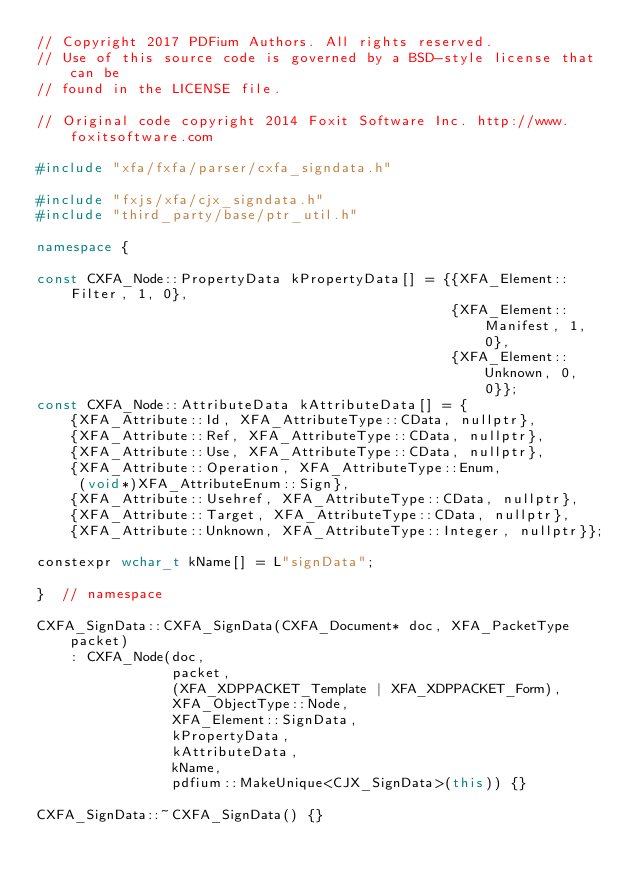<code> <loc_0><loc_0><loc_500><loc_500><_C++_>// Copyright 2017 PDFium Authors. All rights reserved.
// Use of this source code is governed by a BSD-style license that can be
// found in the LICENSE file.

// Original code copyright 2014 Foxit Software Inc. http://www.foxitsoftware.com

#include "xfa/fxfa/parser/cxfa_signdata.h"

#include "fxjs/xfa/cjx_signdata.h"
#include "third_party/base/ptr_util.h"

namespace {

const CXFA_Node::PropertyData kPropertyData[] = {{XFA_Element::Filter, 1, 0},
                                                 {XFA_Element::Manifest, 1, 0},
                                                 {XFA_Element::Unknown, 0, 0}};
const CXFA_Node::AttributeData kAttributeData[] = {
    {XFA_Attribute::Id, XFA_AttributeType::CData, nullptr},
    {XFA_Attribute::Ref, XFA_AttributeType::CData, nullptr},
    {XFA_Attribute::Use, XFA_AttributeType::CData, nullptr},
    {XFA_Attribute::Operation, XFA_AttributeType::Enum,
     (void*)XFA_AttributeEnum::Sign},
    {XFA_Attribute::Usehref, XFA_AttributeType::CData, nullptr},
    {XFA_Attribute::Target, XFA_AttributeType::CData, nullptr},
    {XFA_Attribute::Unknown, XFA_AttributeType::Integer, nullptr}};

constexpr wchar_t kName[] = L"signData";

}  // namespace

CXFA_SignData::CXFA_SignData(CXFA_Document* doc, XFA_PacketType packet)
    : CXFA_Node(doc,
                packet,
                (XFA_XDPPACKET_Template | XFA_XDPPACKET_Form),
                XFA_ObjectType::Node,
                XFA_Element::SignData,
                kPropertyData,
                kAttributeData,
                kName,
                pdfium::MakeUnique<CJX_SignData>(this)) {}

CXFA_SignData::~CXFA_SignData() {}
</code> 